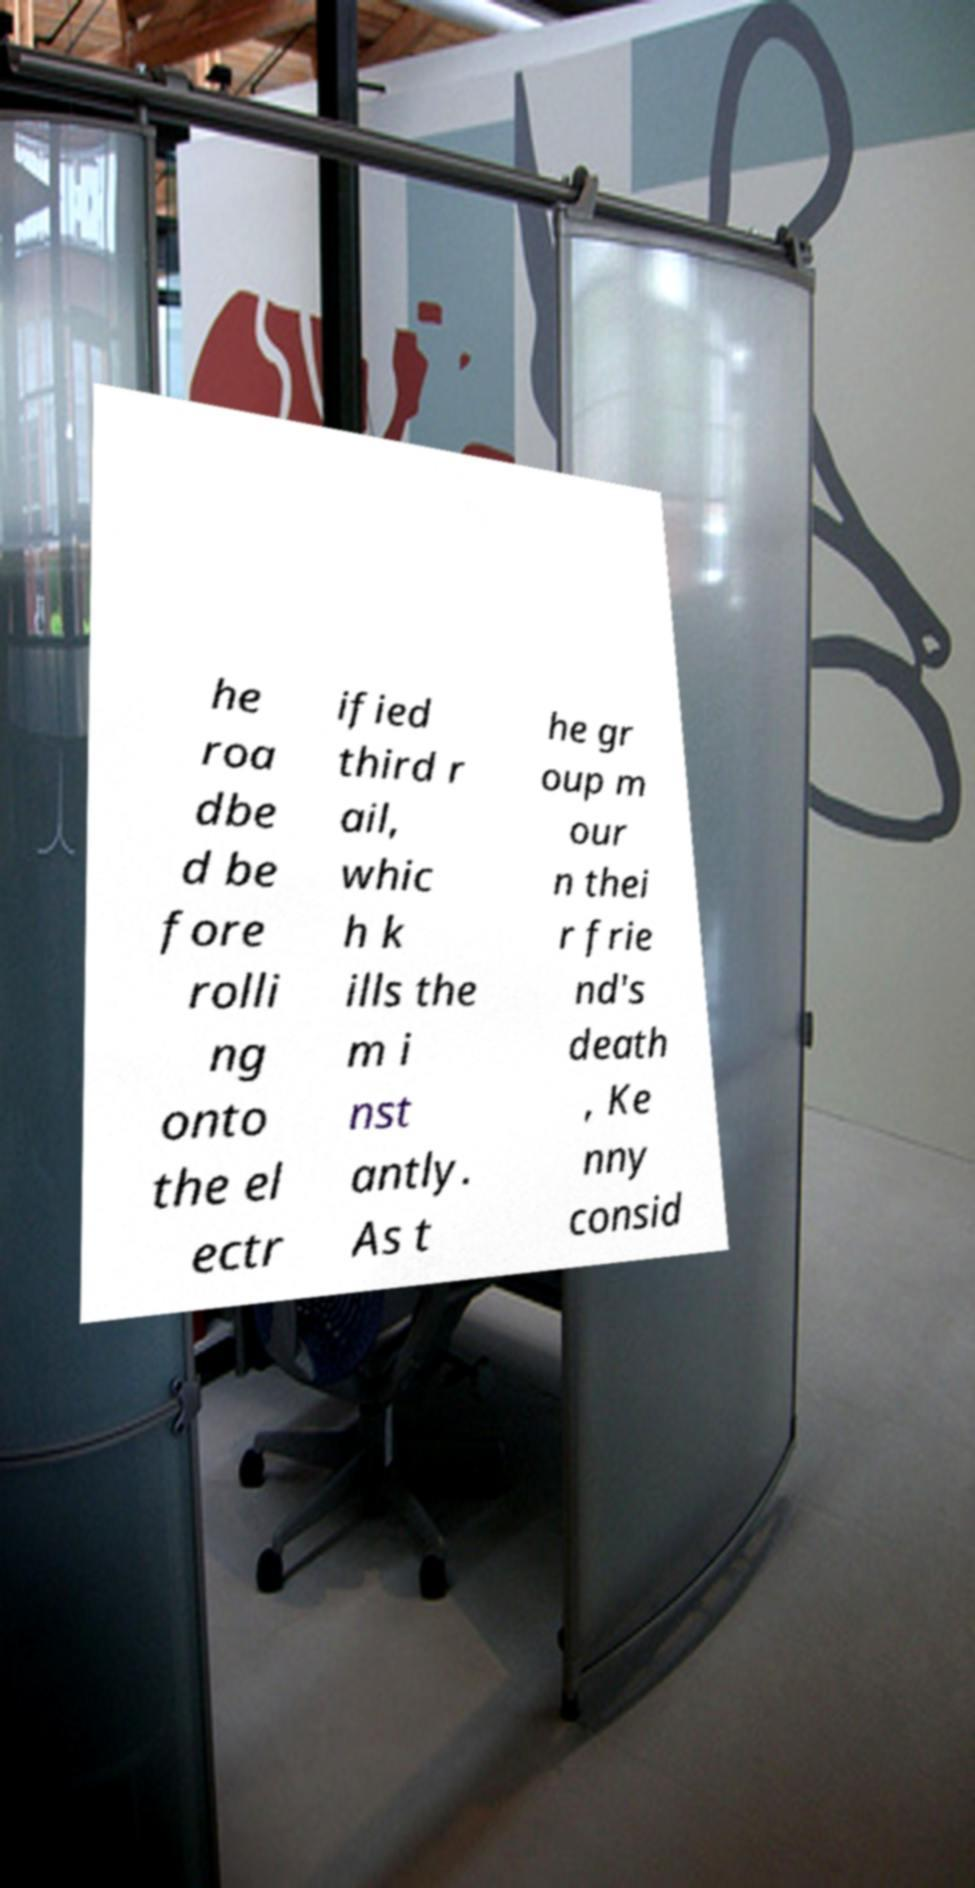Could you assist in decoding the text presented in this image and type it out clearly? he roa dbe d be fore rolli ng onto the el ectr ified third r ail, whic h k ills the m i nst antly. As t he gr oup m our n thei r frie nd's death , Ke nny consid 